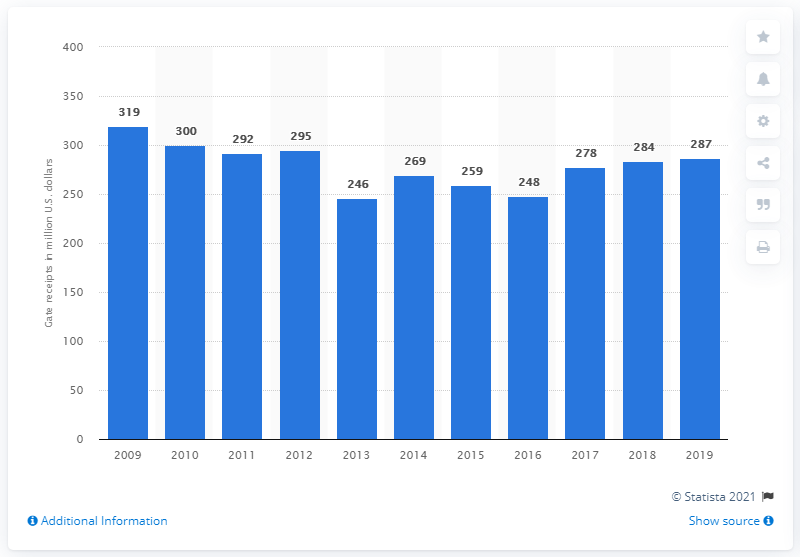Specify some key components in this picture. The gate receipts of the New York Yankees in 2019 were approximately $287 million in dollars. 